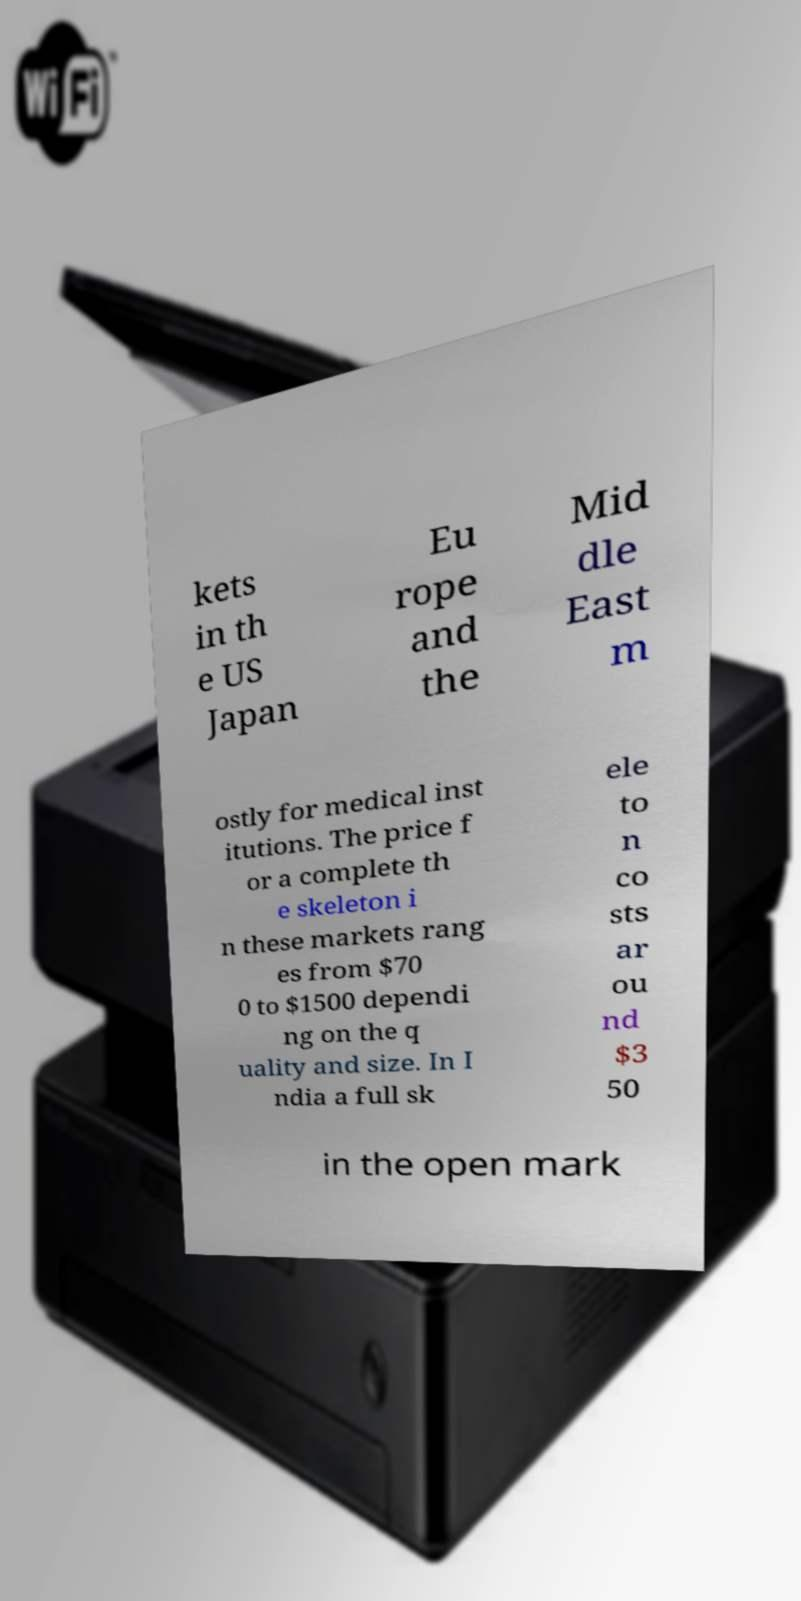Please identify and transcribe the text found in this image. kets in th e US Japan Eu rope and the Mid dle East m ostly for medical inst itutions. The price f or a complete th e skeleton i n these markets rang es from $70 0 to $1500 dependi ng on the q uality and size. In I ndia a full sk ele to n co sts ar ou nd $3 50 in the open mark 